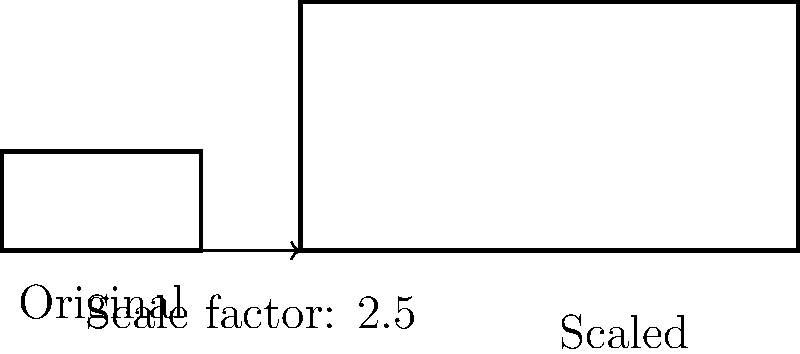The iconic No Doubt logo, originally measuring 2 inches wide and 1 inch tall, is being scaled up for a massive backdrop at their Los Angeles concert. If the new logo needs to be 5 inches wide, what will be its height in inches? Let's approach this step-by-step:

1) First, we need to identify the scale factor. We can do this by comparing the new width to the original width:

   Scale factor = New width / Original width
                = $5 \text{ inches} / 2 \text{ inches} = 2.5$

2) The scale factor tells us that all dimensions of the logo will be multiplied by 2.5.

3) Now, we can use this scale factor to find the new height:

   New height = Original height × Scale factor
              = $1 \text{ inch} \times 2.5 = 2.5 \text{ inches}$

Therefore, when the width is scaled to 5 inches, the height of the new logo will be 2.5 inches.
Answer: $2.5 \text{ inches}$ 